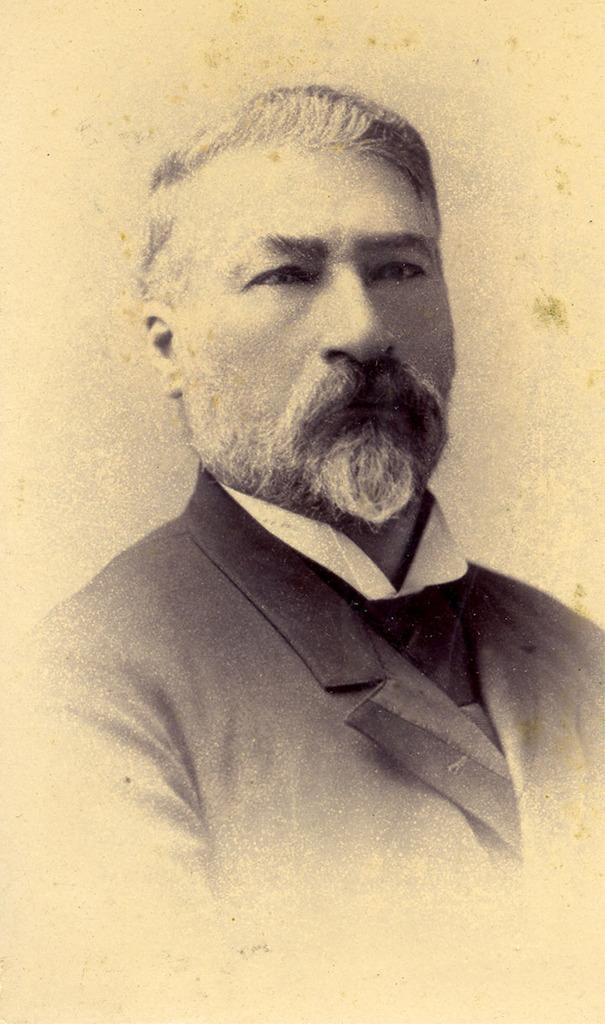Describe this image in one or two sentences. In this picture I can see a man , and there is white background. 